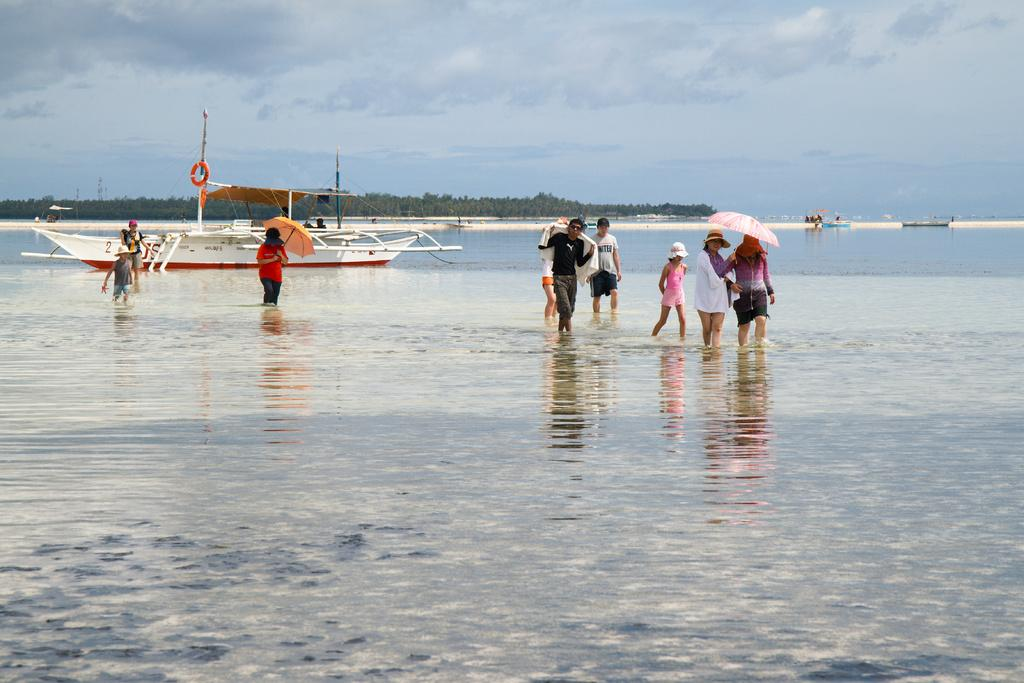What are the people in the image doing on the water? The people in the image are walking on the water. What objects are some people holding in the image? Some people are holding umbrellas in the image. What can be seen on the water in the image? There is a boat on the river in the image. What is visible in the background of the image? Trees and the sky are visible in the background of the image. What type of arch can be seen in the image? There is no arch present in the image. What is the hammer being used for in the image? There is no hammer present in the image. 